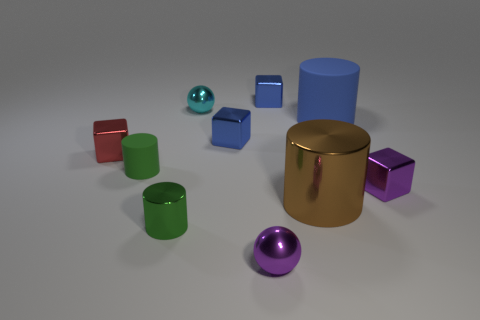There is a small thing that is right of the tiny cyan ball and in front of the big brown metallic thing; what is its shape?
Provide a succinct answer. Sphere. Is the size of the blue shiny cube on the left side of the tiny purple shiny sphere the same as the rubber object that is left of the tiny purple ball?
Offer a very short reply. Yes. How big is the shiny sphere that is in front of the small sphere on the left side of the purple ball right of the tiny metallic cylinder?
Ensure brevity in your answer.  Small. There is a small purple object on the right side of the small ball that is in front of the blue cylinder; what shape is it?
Your response must be concise. Cube. Do the metal sphere that is left of the purple ball and the tiny metal cylinder have the same color?
Your response must be concise. No. What is the color of the cube that is in front of the small cyan metal sphere and behind the small red cube?
Provide a succinct answer. Blue. Are there any brown spheres made of the same material as the small purple sphere?
Offer a terse response. No. What size is the cyan object?
Provide a succinct answer. Small. What size is the blue metal block behind the big blue rubber object that is behind the small matte cylinder?
Your answer should be very brief. Small. What material is the purple object that is the same shape as the red object?
Offer a very short reply. Metal. 